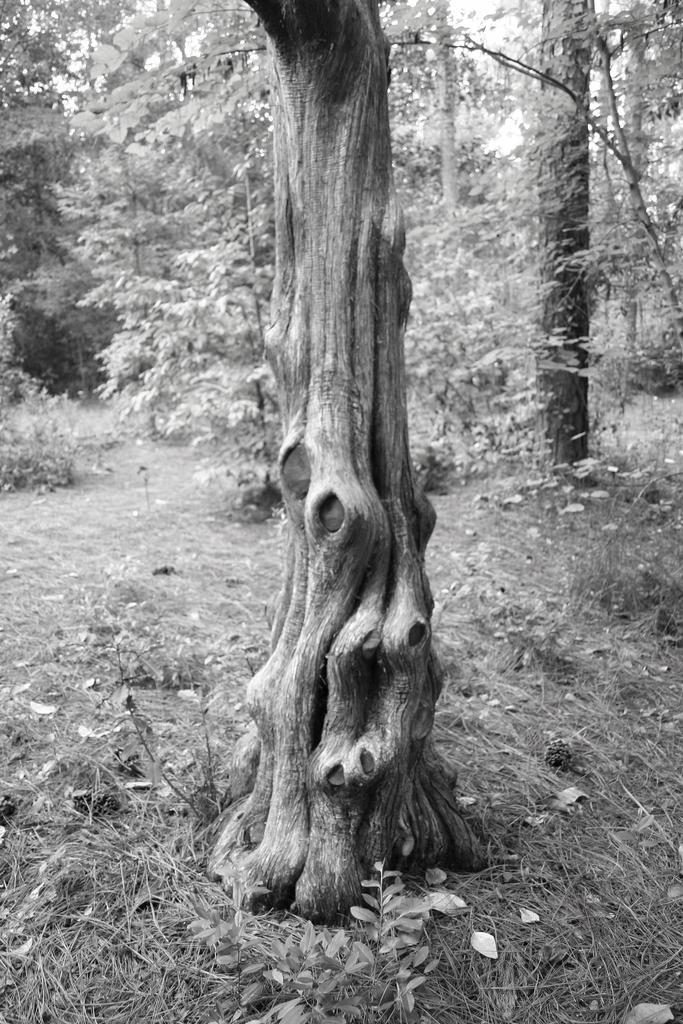What is the color scheme of the image? The image is black and white. What can be seen in the image that is made of wood? There is a tree trunk in the image. What type of vegetation is present in the image? There is grass in the image. What type of trees are visible in the image? There are trees with branches and leaves in the image. How much debt is represented by the tree trunk in the image? There is no representation of debt in the image; it only features a tree trunk, grass, and trees with branches and leaves. How many swings can be seen in the image? There are no swings present in the image. 